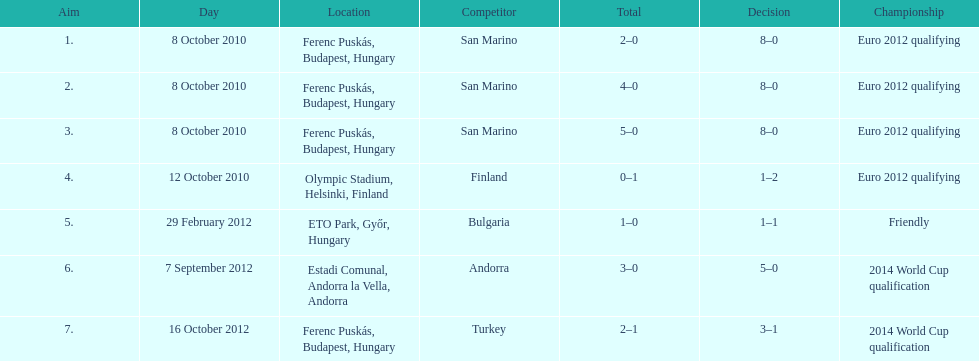How many goals were scored at the euro 2012 qualifying competition? 12. 